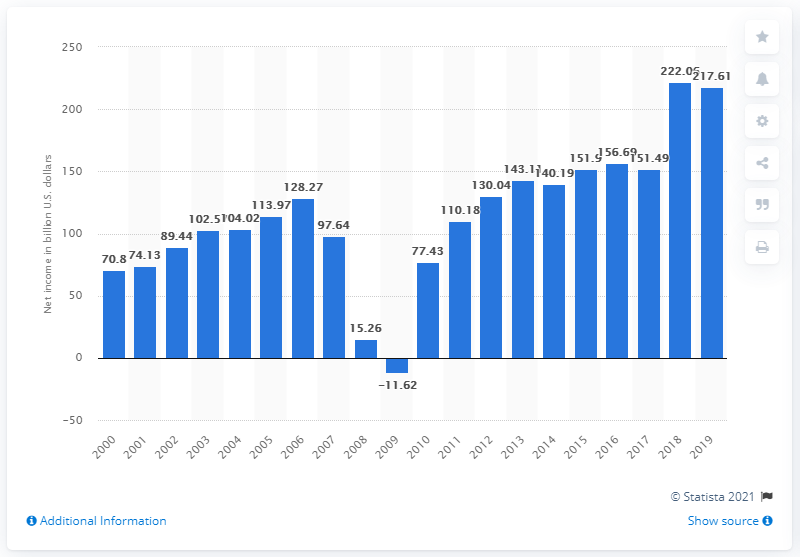Identify some key points in this picture. In the year 2000, the net income of FDIC-insured commercial banks was the second highest value among all years. In 2019, the net income of FDIC-insured commercial banks in the United States was $217.61 billion. 